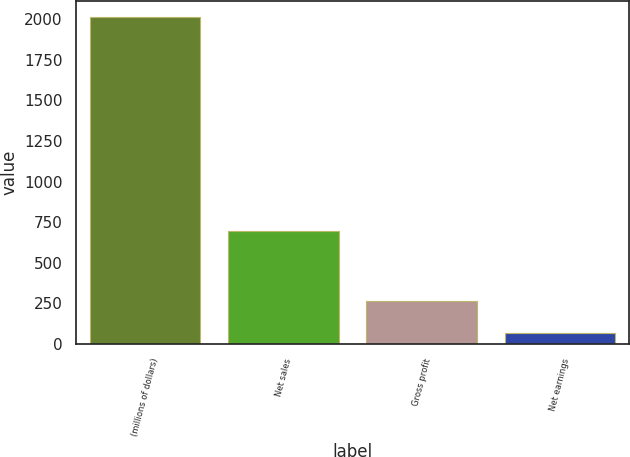<chart> <loc_0><loc_0><loc_500><loc_500><bar_chart><fcel>(millions of dollars)<fcel>Net sales<fcel>Gross profit<fcel>Net earnings<nl><fcel>2012<fcel>696.7<fcel>262.85<fcel>68.5<nl></chart> 